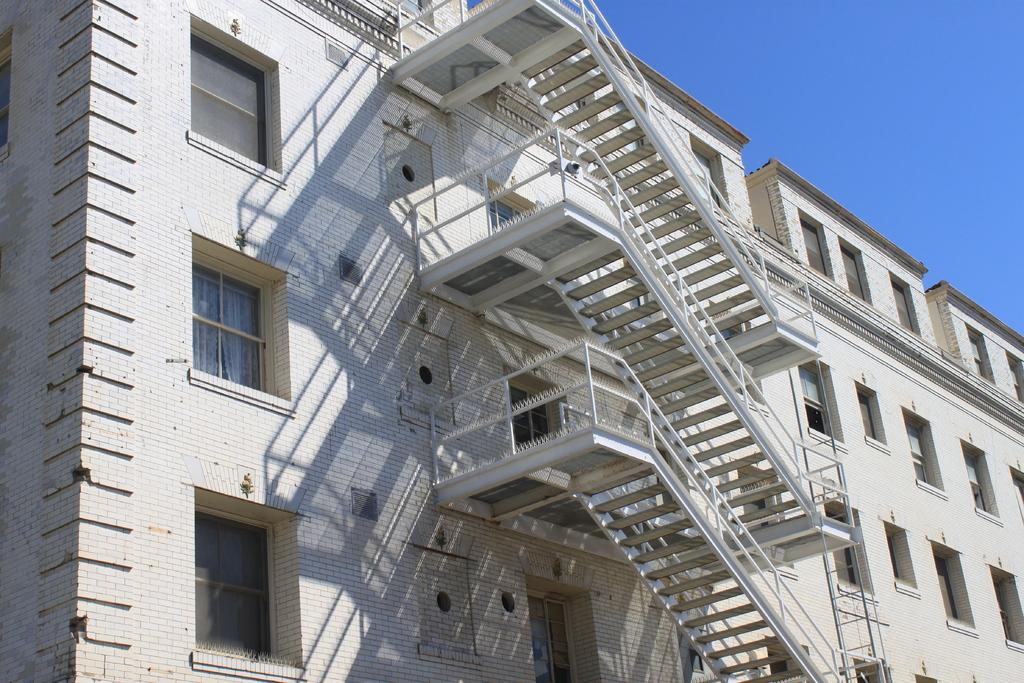What type of structure is visible in the image? There is a building in the image. What architectural feature can be seen on the building? The building has multiple windows. Are there any interior features visible in the image? Yes, there are staircases present in the building. What is the condition of the sky in the image? The sky is clear in the image. Where is the queen sitting on her throne in the image? There is no queen or throne present in the image; it features a building with windows and staircases. 